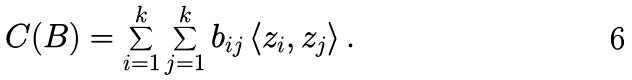<formula> <loc_0><loc_0><loc_500><loc_500>C ( B ) = \sum _ { i = 1 } ^ { k } \sum _ { j = 1 } ^ { k } b _ { i j } \left \langle z _ { i } , z _ { j } \right \rangle .</formula> 